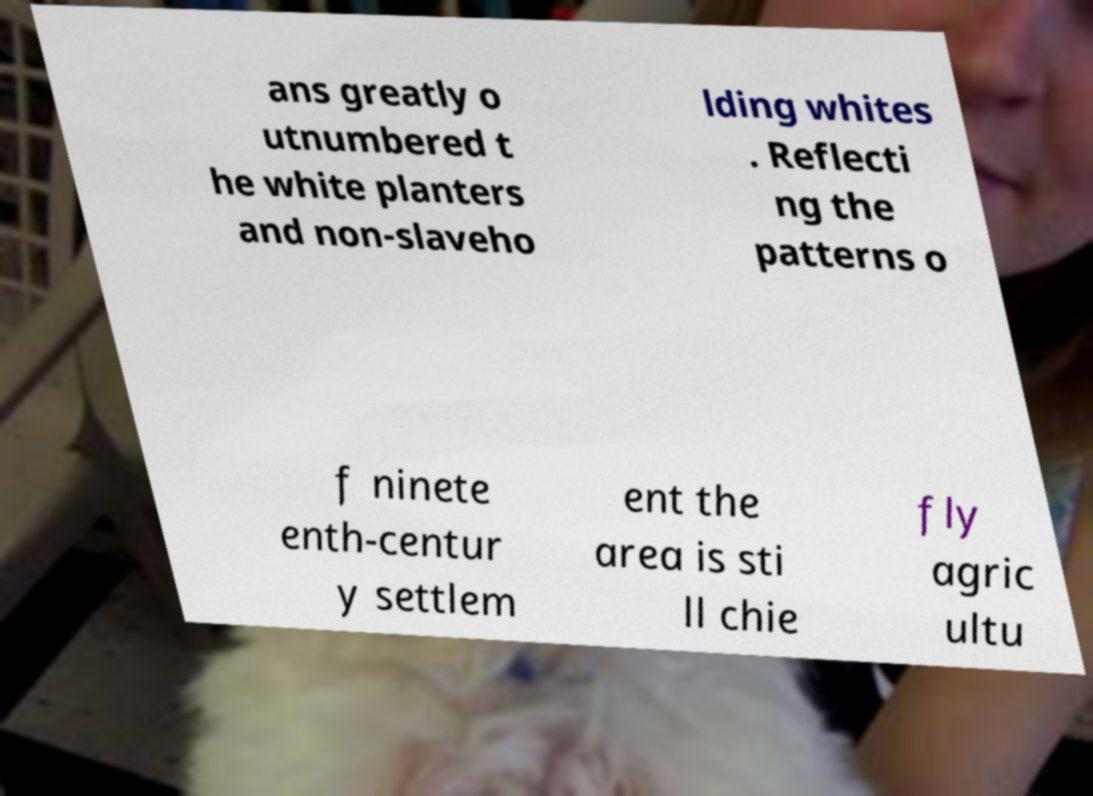Could you extract and type out the text from this image? ans greatly o utnumbered t he white planters and non-slaveho lding whites . Reflecti ng the patterns o f ninete enth-centur y settlem ent the area is sti ll chie fly agric ultu 